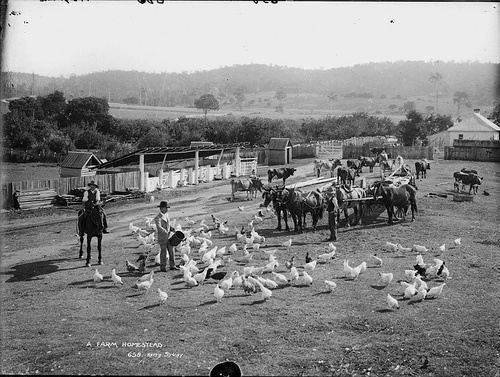Describe the objects in this image and their specific colors. I can see bird in black, darkgray, gray, and lightgray tones, horse in black, gray, darkgray, and lightgray tones, horse in black, gray, darkgray, and lightgray tones, horse in black, gray, darkgray, and lightgray tones, and people in black, gray, darkgray, and lightgray tones in this image. 